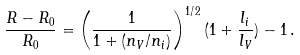Convert formula to latex. <formula><loc_0><loc_0><loc_500><loc_500>\frac { R - R _ { 0 } } { R _ { 0 } } = \left ( \frac { 1 } { 1 + ( n _ { V } / n _ { i } ) } \right ) ^ { 1 / 2 } ( 1 + \frac { l _ { i } } { l _ { V } } ) - 1 \, .</formula> 